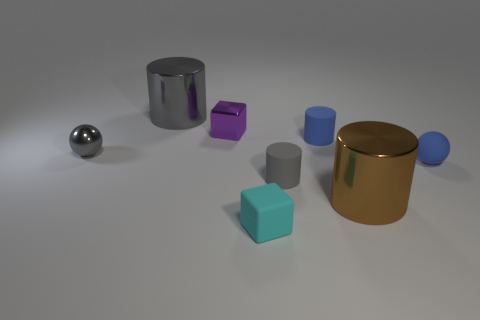How many small blue things are there?
Offer a terse response. 2. There is a tiny sphere that is made of the same material as the cyan cube; what is its color?
Ensure brevity in your answer.  Blue. What number of large objects are either blue balls or blue cylinders?
Your answer should be very brief. 0. How many large brown objects are left of the large brown metal object?
Keep it short and to the point. 0. What is the color of the metallic object that is the same shape as the small cyan rubber thing?
Make the answer very short. Purple. How many matte things are small cyan blocks or tiny cylinders?
Your answer should be compact. 3. Is there a small blue object behind the gray cylinder that is behind the tiny purple metallic thing that is behind the gray metallic ball?
Provide a short and direct response. No. What is the color of the small metal ball?
Give a very brief answer. Gray. Does the tiny gray rubber object on the right side of the small purple thing have the same shape as the big brown metallic object?
Your response must be concise. Yes. How many things are either small things or matte cylinders behind the small gray shiny sphere?
Offer a very short reply. 6. 